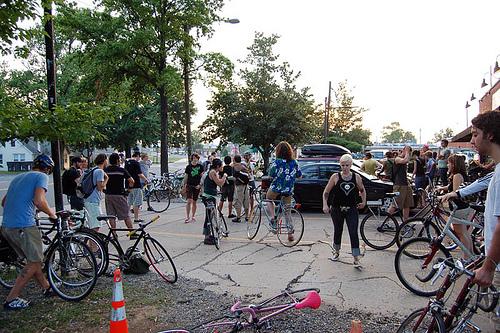Does the pink bike have training wheels?
Give a very brief answer. No. Is this a bike club?
Write a very short answer. Yes. Is it night time?
Short answer required. No. Are all these people holding bicycles?
Concise answer only. No. 